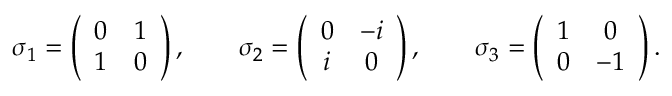<formula> <loc_0><loc_0><loc_500><loc_500>\sigma _ { 1 } = \left ( \begin{array} { c c } { 0 } & { 1 } \\ { 1 } & { 0 } \end{array} \right ) , \quad \sigma _ { 2 } = \left ( \begin{array} { c c } { 0 } & { - i } \\ { i } & { 0 } \end{array} \right ) , \quad \sigma _ { 3 } = \left ( \begin{array} { c c } { 1 } & { 0 } \\ { 0 } & { - 1 } \end{array} \right ) .</formula> 